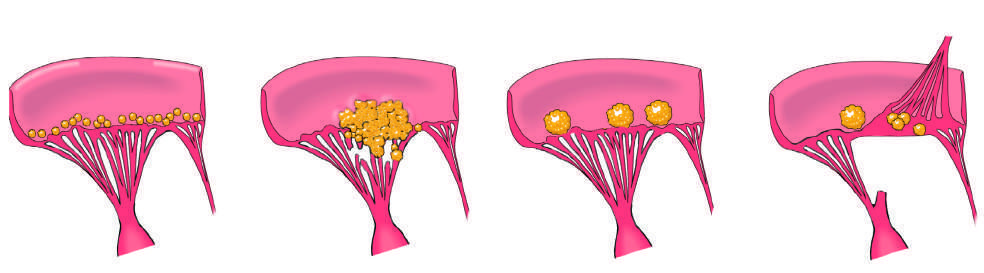what manifests with small - to medium-sized, bland, nondestructive vegetations at the line of valve closure?
Answer the question using a single word or phrase. Non-bacterial thrombotic endocarditis (nbte) 